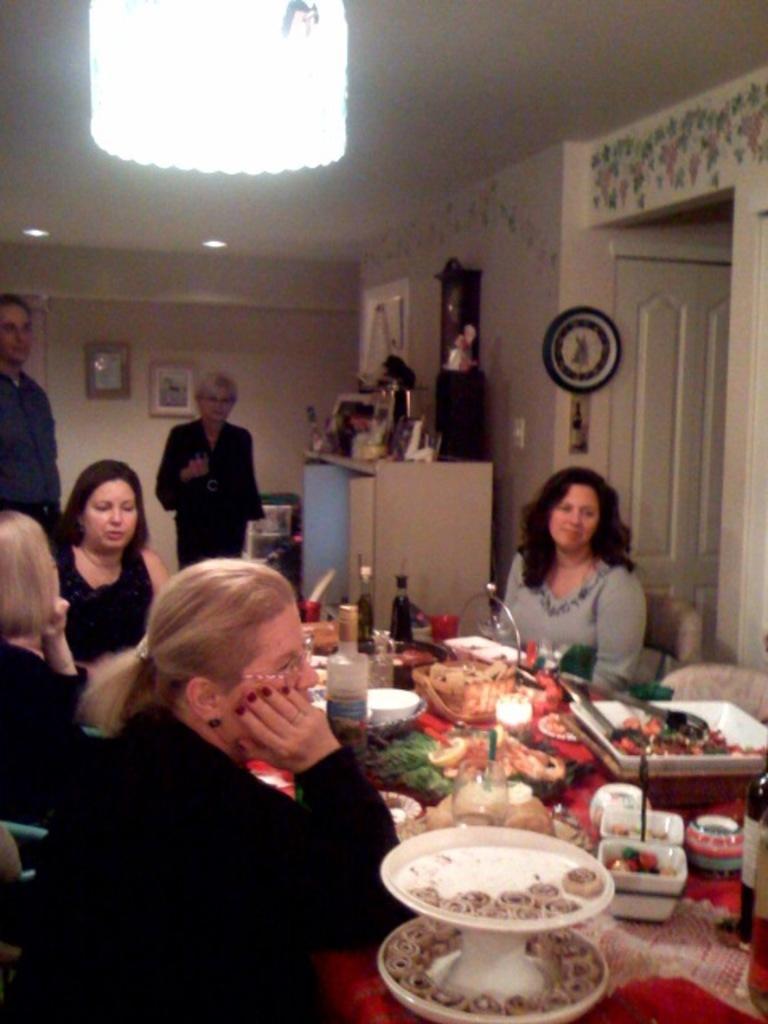Can you describe this image briefly? There are people sitting around the table in the foreground area of the image, there are bottles, glasses, plates and food items on the table, there are frames, it seems like a cupboard, clock, door, lamps and other objects in the background, it seems like a chandelier at the top side. 